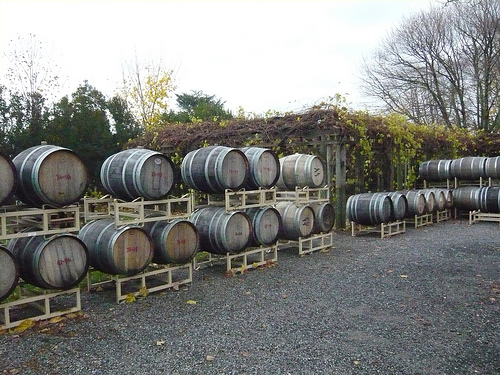<image>
Can you confirm if the barrel is behind the rack? No. The barrel is not behind the rack. From this viewpoint, the barrel appears to be positioned elsewhere in the scene. Is the barrel above the ground? Yes. The barrel is positioned above the ground in the vertical space, higher up in the scene. Is there a bottom above the stand? No. The bottom is not positioned above the stand. The vertical arrangement shows a different relationship. 